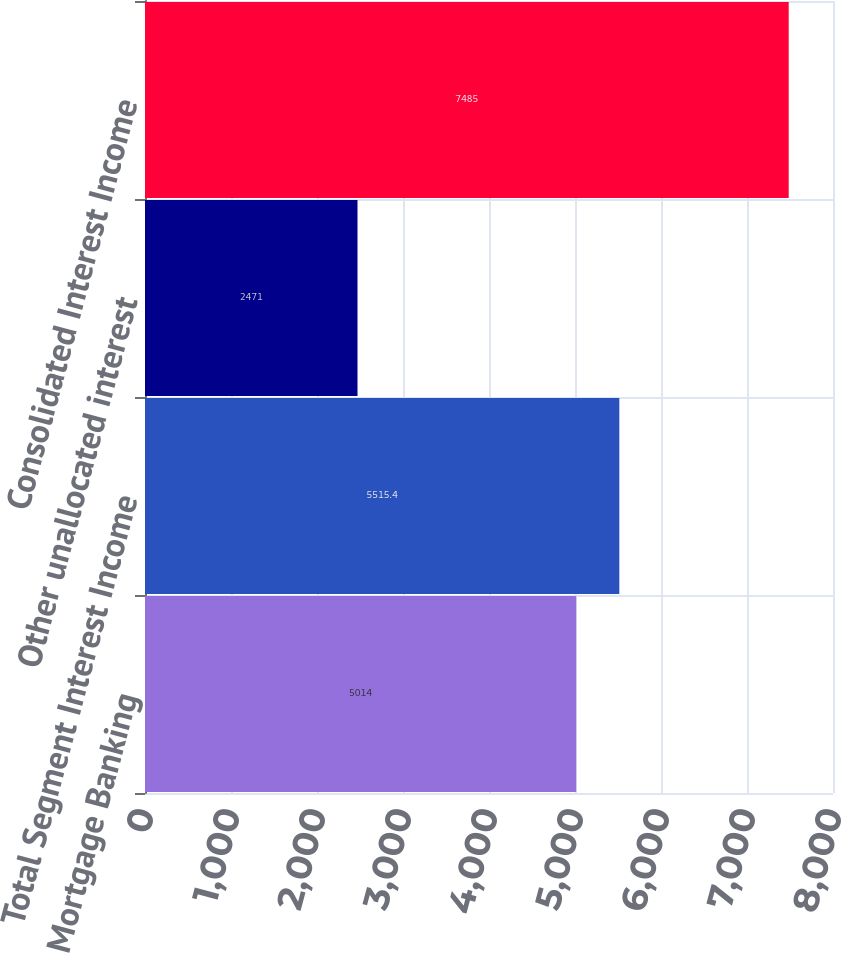Convert chart to OTSL. <chart><loc_0><loc_0><loc_500><loc_500><bar_chart><fcel>Mortgage Banking<fcel>Total Segment Interest Income<fcel>Other unallocated interest<fcel>Consolidated Interest Income<nl><fcel>5014<fcel>5515.4<fcel>2471<fcel>7485<nl></chart> 